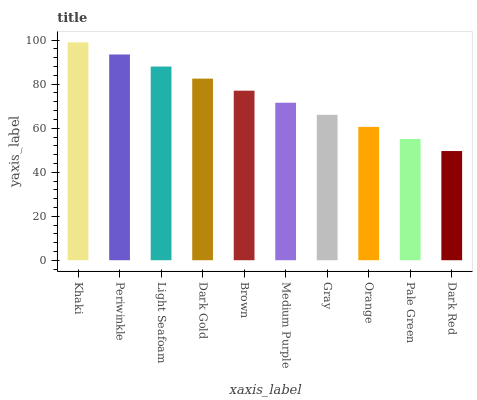Is Dark Red the minimum?
Answer yes or no. Yes. Is Khaki the maximum?
Answer yes or no. Yes. Is Periwinkle the minimum?
Answer yes or no. No. Is Periwinkle the maximum?
Answer yes or no. No. Is Khaki greater than Periwinkle?
Answer yes or no. Yes. Is Periwinkle less than Khaki?
Answer yes or no. Yes. Is Periwinkle greater than Khaki?
Answer yes or no. No. Is Khaki less than Periwinkle?
Answer yes or no. No. Is Brown the high median?
Answer yes or no. Yes. Is Medium Purple the low median?
Answer yes or no. Yes. Is Dark Gold the high median?
Answer yes or no. No. Is Khaki the low median?
Answer yes or no. No. 